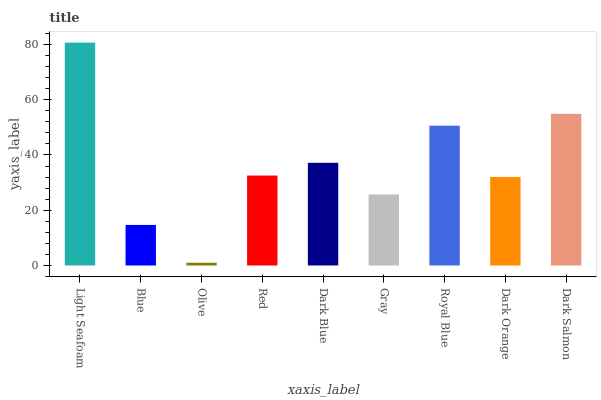Is Blue the minimum?
Answer yes or no. No. Is Blue the maximum?
Answer yes or no. No. Is Light Seafoam greater than Blue?
Answer yes or no. Yes. Is Blue less than Light Seafoam?
Answer yes or no. Yes. Is Blue greater than Light Seafoam?
Answer yes or no. No. Is Light Seafoam less than Blue?
Answer yes or no. No. Is Red the high median?
Answer yes or no. Yes. Is Red the low median?
Answer yes or no. Yes. Is Dark Salmon the high median?
Answer yes or no. No. Is Royal Blue the low median?
Answer yes or no. No. 